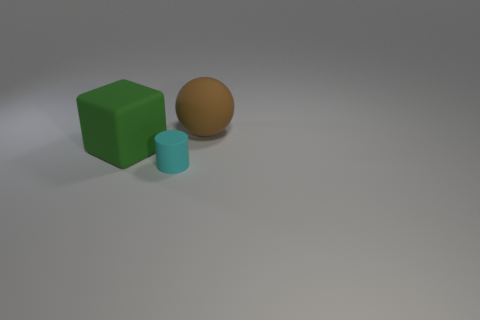Is there a large cube behind the large thing that is left of the large matte object that is behind the rubber block?
Ensure brevity in your answer.  No. How many blocks are large green objects or cyan rubber objects?
Give a very brief answer. 1. There is a cyan matte object; is its shape the same as the rubber thing that is behind the block?
Offer a terse response. No. Are there fewer large brown things in front of the big matte ball than green blocks?
Provide a short and direct response. Yes. There is a tiny matte object; are there any big brown matte spheres to the left of it?
Keep it short and to the point. No. Are there any large gray matte objects that have the same shape as the small thing?
Your answer should be compact. No. The object that is the same size as the green cube is what shape?
Offer a very short reply. Sphere. What number of objects are objects behind the small matte cylinder or small cyan objects?
Your answer should be compact. 3. Does the rubber block have the same color as the small matte cylinder?
Offer a terse response. No. There is a thing on the right side of the cyan cylinder; what is its size?
Give a very brief answer. Large. 